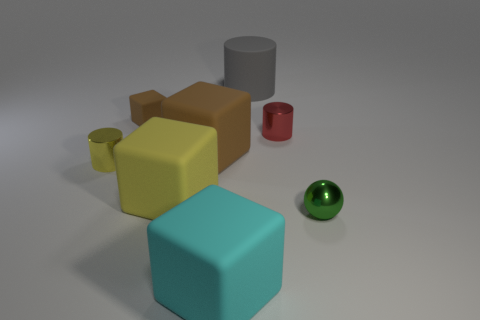Add 1 balls. How many objects exist? 9 Subtract all tiny cylinders. How many cylinders are left? 1 Subtract all gray cylinders. How many brown blocks are left? 2 Subtract all cylinders. How many objects are left? 5 Subtract 1 balls. How many balls are left? 0 Subtract all red cylinders. How many cylinders are left? 2 Subtract all gray objects. Subtract all small green spheres. How many objects are left? 6 Add 1 green shiny objects. How many green shiny objects are left? 2 Add 1 cyan matte things. How many cyan matte things exist? 2 Subtract 0 green cylinders. How many objects are left? 8 